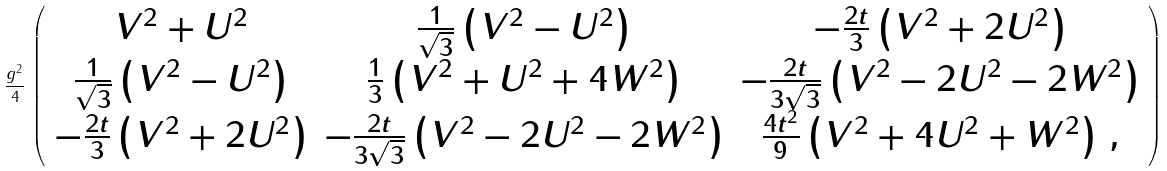<formula> <loc_0><loc_0><loc_500><loc_500>\frac { g ^ { 2 } } { 4 } \, \left ( \begin{array} { c c c } V ^ { 2 } + U ^ { 2 } & \frac { 1 } { \sqrt { 3 } } \left ( V ^ { 2 } - U ^ { 2 } \right ) & - \frac { 2 t } { 3 } \left ( V ^ { 2 } + 2 U ^ { 2 } \right ) \\ \frac { 1 } { \sqrt { 3 } } \left ( V ^ { 2 } - U ^ { 2 } \right ) & \frac { 1 } { 3 } \left ( V ^ { 2 } + U ^ { 2 } + 4 W ^ { 2 } \right ) & - \frac { 2 t } { 3 \sqrt { 3 } } \left ( V ^ { 2 } - 2 U ^ { 2 } - 2 W ^ { 2 } \right ) \\ - \frac { 2 t } { 3 } \left ( V ^ { 2 } + 2 U ^ { 2 } \right ) & - \frac { 2 t } { 3 \sqrt { 3 } } \left ( V ^ { 2 } - 2 U ^ { 2 } - 2 W ^ { 2 } \right ) & \frac { 4 t ^ { 2 } } { 9 } \left ( V ^ { 2 } + 4 U ^ { 2 } + W ^ { 2 } \right ) \, , \end{array} \right )</formula> 